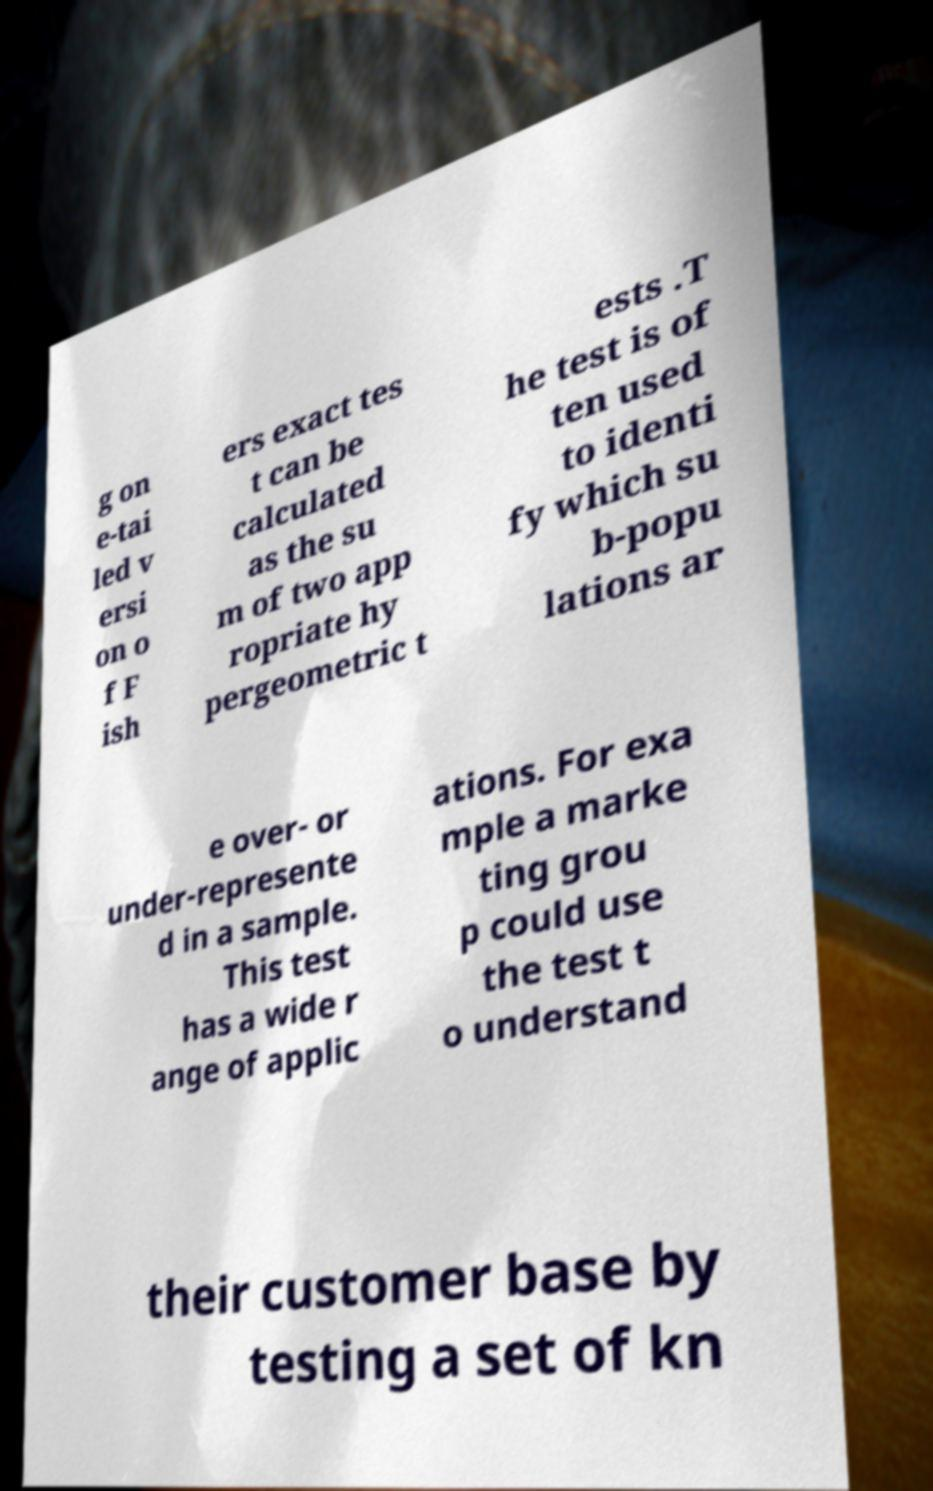There's text embedded in this image that I need extracted. Can you transcribe it verbatim? g on e-tai led v ersi on o f F ish ers exact tes t can be calculated as the su m of two app ropriate hy pergeometric t ests .T he test is of ten used to identi fy which su b-popu lations ar e over- or under-represente d in a sample. This test has a wide r ange of applic ations. For exa mple a marke ting grou p could use the test t o understand their customer base by testing a set of kn 